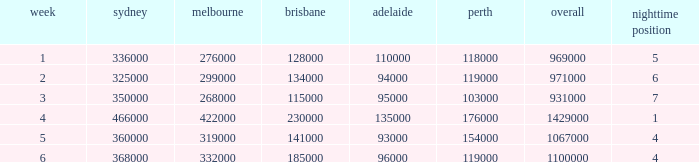What was the rating for Brisbane the week that Adelaide had 94000? 134000.0. 